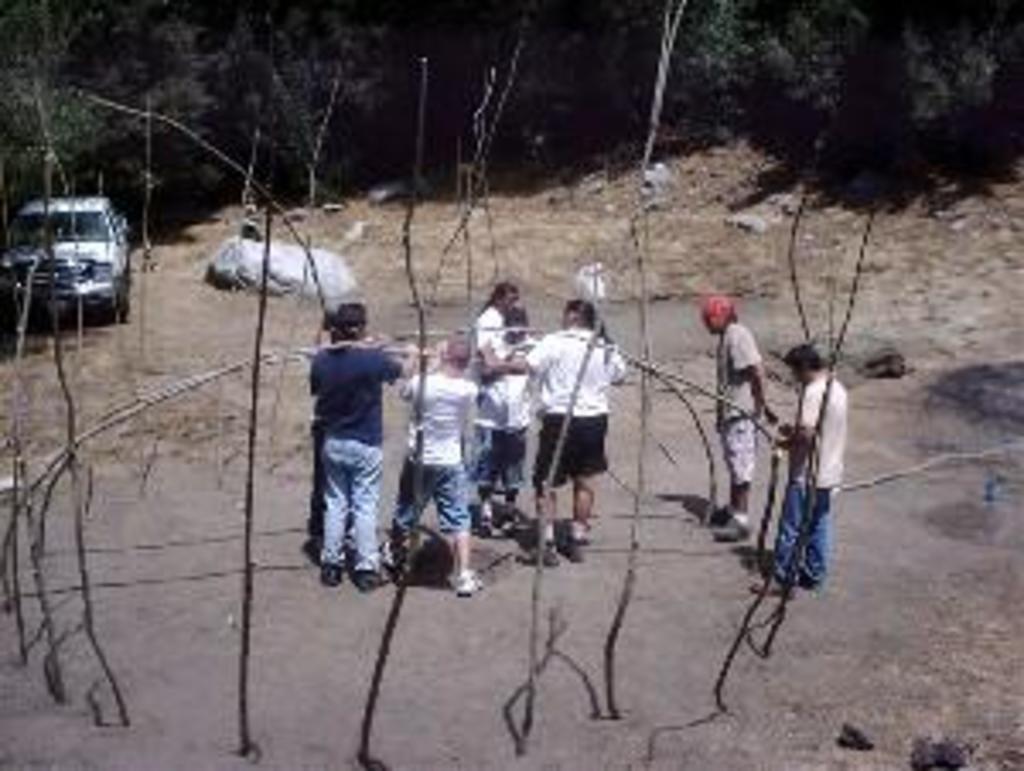Describe this image in one or two sentences. In this picture I can see group of people standing, these are looking like wooden staffs, there is a vehicle, and in the background there are trees. 